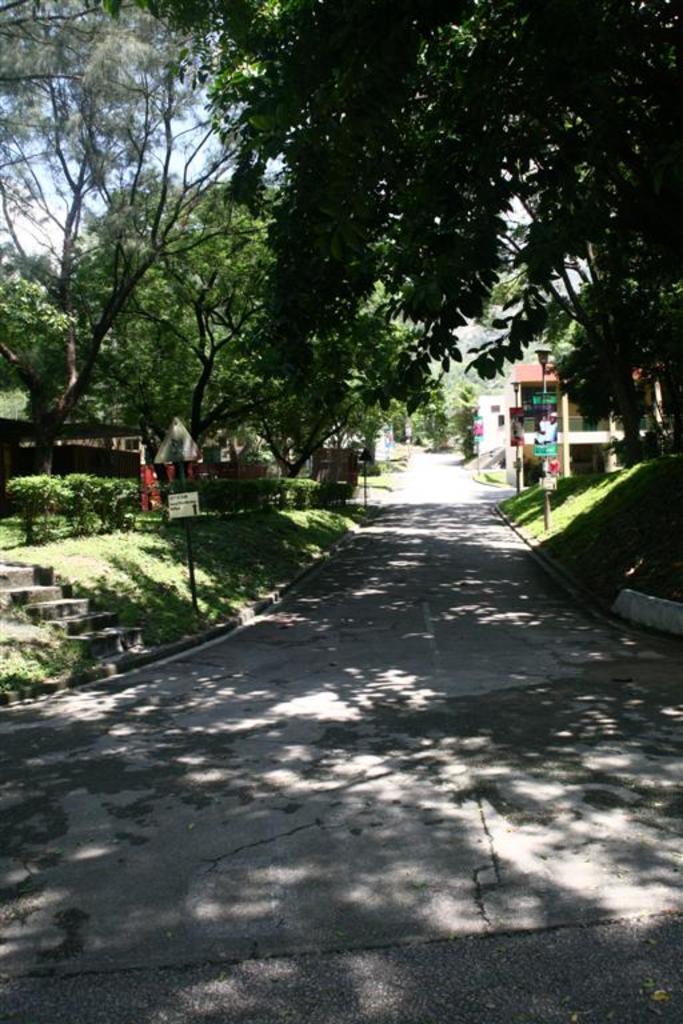In one or two sentences, can you explain what this image depicts? In the center of the image there is a road. In the background, we can see the sky, trees, plants, buildings, grass and a few other objects. 